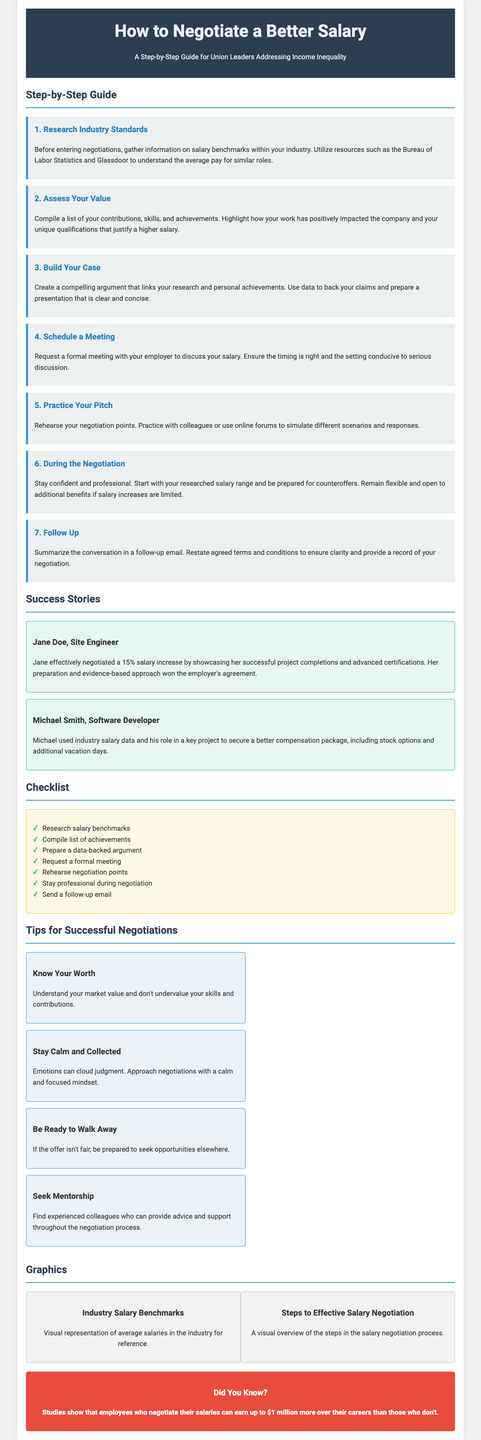What is the title of the document? The title of the document is prominently displayed in the header section.
Answer: How to Negotiate a Better Salary What are the first three steps in the guide? The first three steps are clearly listed in the respective sections of the document.
Answer: Research Industry Standards, Assess Your Value, Build Your Case How much salary increase did Jane Doe negotiate? This information is provided in her success story section where her achievements are cited.
Answer: 15% What is one of the tips for successful negotiations? Tips are provided as short phrases within the tips section of the document.
Answer: Know Your Worth What is included in the checklist? The checklist contains actionable items that can be derived from the document's negotiation steps.
Answer: Research salary benchmarks What color is the callout section? The callout section is highlighted to emphasize its importance and is visually distinct in color.
Answer: Red How many success stories are presented in the document? The number of success stories can be counted from the section detailing individual experiences.
Answer: 2 What graphic is suggested for Industry Salary Benchmarks? The graphic section describes visual representations related to salary data.
Answer: Average salaries in the industry What should you do after the negotiation? The document specifies the necessary action to take following the negotiation process.
Answer: Follow-up email 